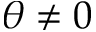<formula> <loc_0><loc_0><loc_500><loc_500>\theta \neq 0</formula> 